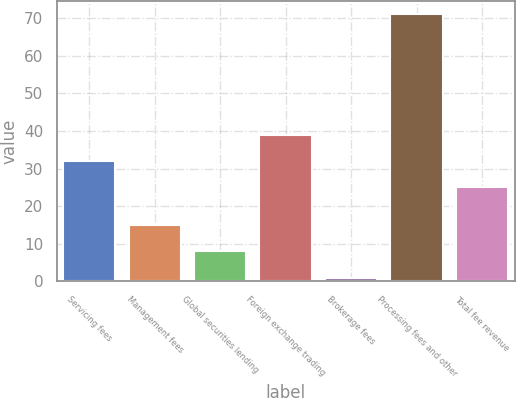Convert chart to OTSL. <chart><loc_0><loc_0><loc_500><loc_500><bar_chart><fcel>Servicing fees<fcel>Management fees<fcel>Global securities lending<fcel>Foreign exchange trading<fcel>Brokerage fees<fcel>Processing fees and other<fcel>Total fee revenue<nl><fcel>32<fcel>15<fcel>8<fcel>39<fcel>1<fcel>71<fcel>25<nl></chart> 